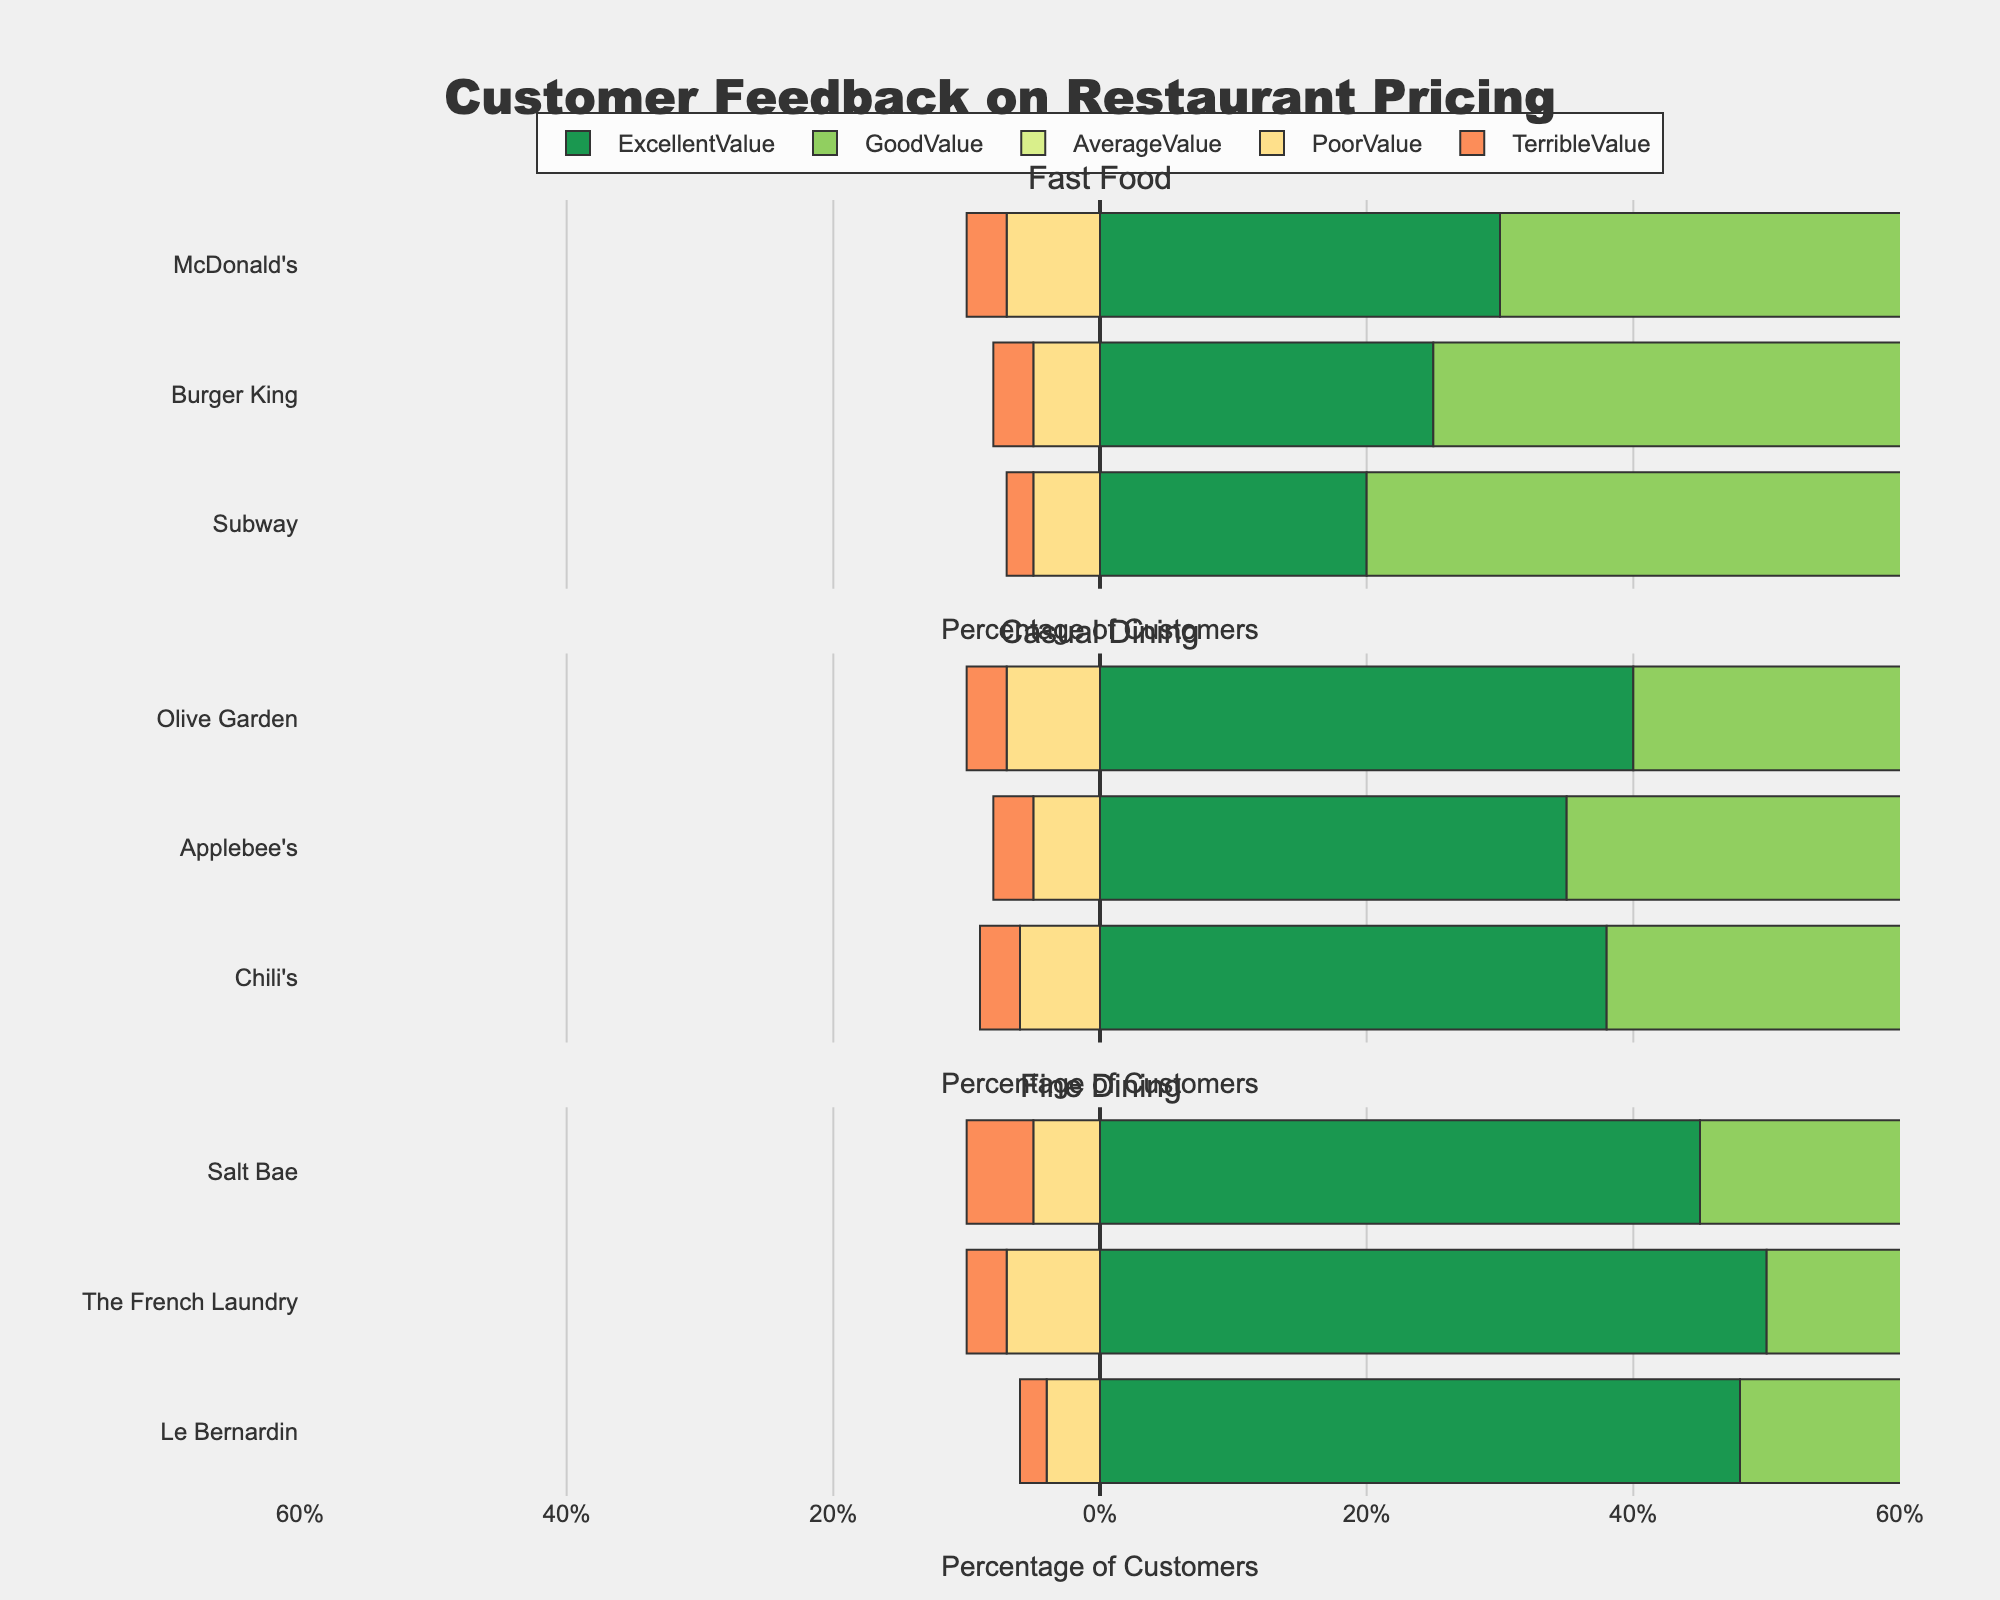How does the percentage of "Excellent Value" ratings at McDonald's compare to that at Subway? McDonald's has 30% "Excellent Value" ratings and Subway has 20%. Comparing the two: 30% > 20%.
Answer: McDonald's Which fast food restaurant received the highest percentage of "Good Value" ratings? Looking at the "Good Value" bar for all fast food restaurants, Subway has the highest value at 50%.
Answer: Subway Add up the percentage of "Excellent Value" and "Good Value" ratings for Olive Garden. Olive Garden has 40% "Excellent Value" and 35% "Good Value". Summing up: 40% + 35% = 75%.
Answer: 75% Are there any restaurants that have the same percentage of "Average Value" ratings? Checking all restaurants, The French Laundry and Le Bernardin both have 15% "Average Value".
Answer: The French Laundry, Le Bernardin Which restaurant in the "Fine Dining" category has the highest combined percentage of "Excellent Value" and "Good Value" ratings? For Fine Dining: Salt Bae (45% + 30% = 75%), The French Laundry (50% + 25% = 75%), and Le Bernardin (48% + 28% = 76%). Le Bernardin has the highest at 76%.
Answer: Le Bernardin What is the difference in "Poor Value" ratings between Burger King and Applebee’s? Burger King has 5% "Poor Value" and Applebee’s has 5%. The difference is 5% - 5% = 0%.
Answer: 0% Which casual dining restaurant has the least percentage of "Terrible Value" ratings? Among casual dining, Olive Garden, Applebee's, and Chili’s all have 3% "Terrible Value". Thus, no difference.
Answer: Olive Garden, Applebee's, Chili's What's the total percentage of negative ratings ("Poor Value" and "Terrible Value") for The French Laundry? The French Laundry has 7% "Poor Value" and 3% "Terrible Value". Summing up: 7% + 3% = 10%.
Answer: 10% Compare the total percentage of positive ratings ("Excellent Value" and "Good Value") between Burger King and Chili’s. Burger King has 25% "Excellent Value" and 45% "Good Value" (total = 70%). Chili’s has 38% "Excellent Value" and 37% "Good Value" (total = 75%).
Answer: Chili's 